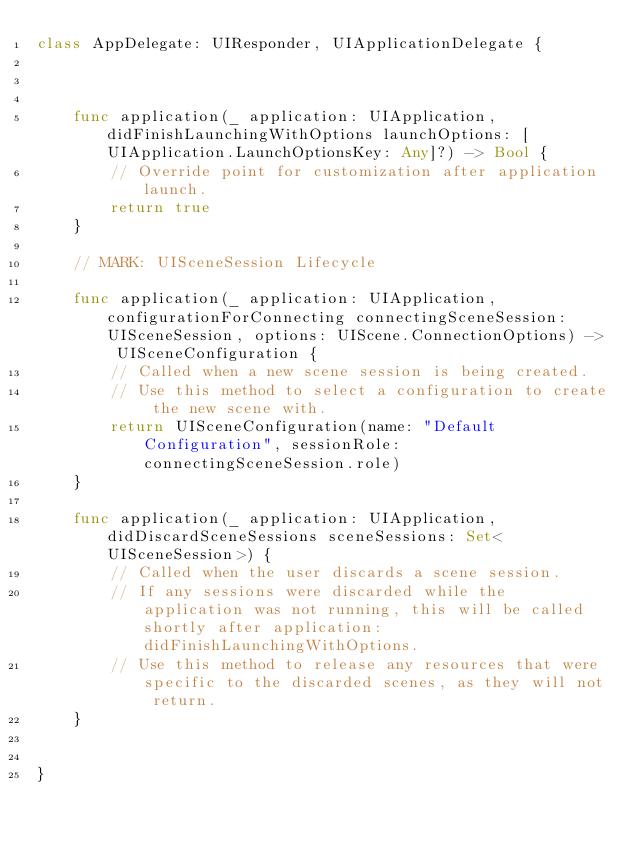Convert code to text. <code><loc_0><loc_0><loc_500><loc_500><_Swift_>class AppDelegate: UIResponder, UIApplicationDelegate {



    func application(_ application: UIApplication, didFinishLaunchingWithOptions launchOptions: [UIApplication.LaunchOptionsKey: Any]?) -> Bool {
        // Override point for customization after application launch.
        return true
    }

    // MARK: UISceneSession Lifecycle

    func application(_ application: UIApplication, configurationForConnecting connectingSceneSession: UISceneSession, options: UIScene.ConnectionOptions) -> UISceneConfiguration {
        // Called when a new scene session is being created.
        // Use this method to select a configuration to create the new scene with.
        return UISceneConfiguration(name: "Default Configuration", sessionRole: connectingSceneSession.role)
    }

    func application(_ application: UIApplication, didDiscardSceneSessions sceneSessions: Set<UISceneSession>) {
        // Called when the user discards a scene session.
        // If any sessions were discarded while the application was not running, this will be called shortly after application:didFinishLaunchingWithOptions.
        // Use this method to release any resources that were specific to the discarded scenes, as they will not return.
    }


}

</code> 